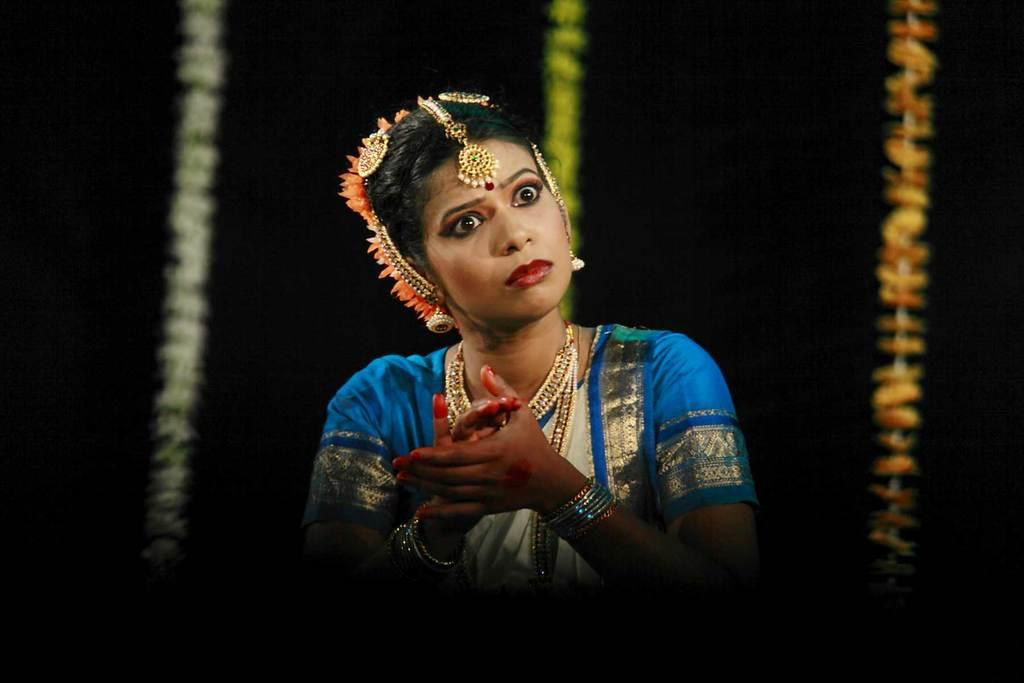Who is the main subject in the image? There is a woman in the center of the picture. What is the woman wearing? The woman is wearing traditional clothing. What can be seen in the background of the image? There are flowers in the background of the image. What time of day is it in the image, and how many bits are visible? The time of day cannot be determined from the image, and there are no bits visible in the image. 